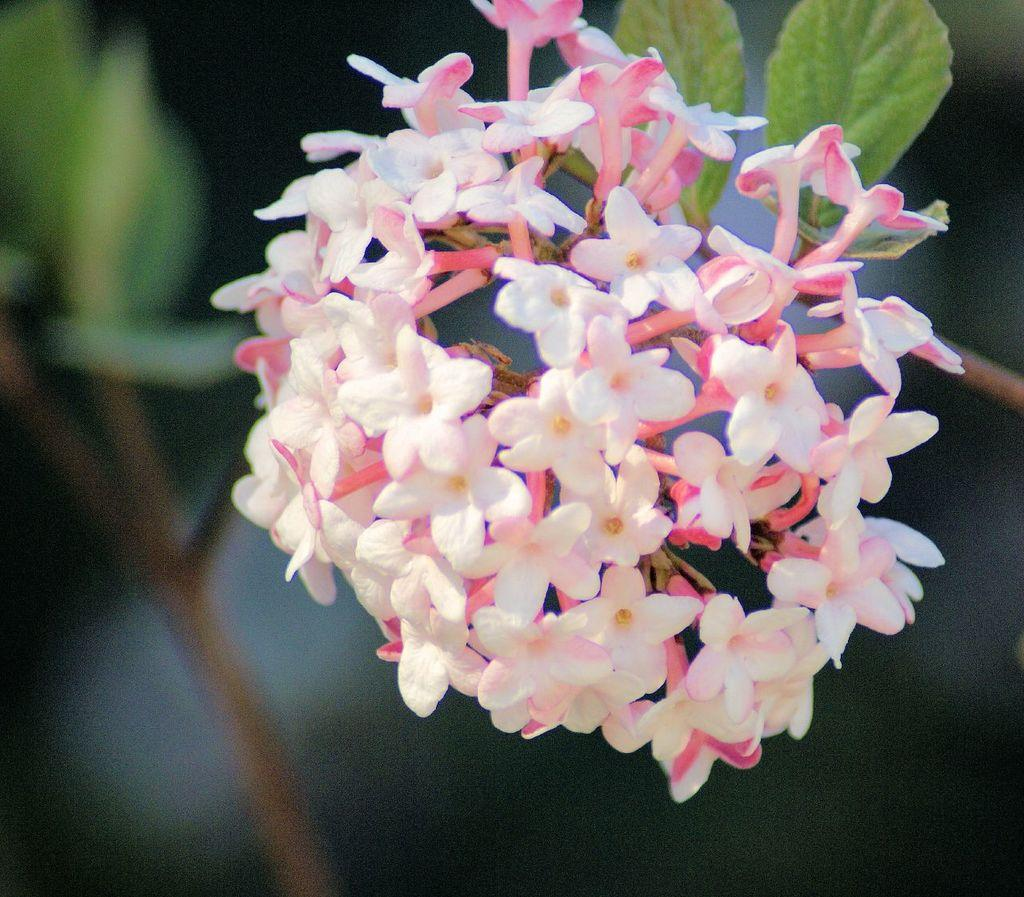What type of plants can be seen in the image? There are flowers and leaves in the image. Can you describe the background of the image? The background of the image is blurry. How many legs can be seen on the hill in the image? There is no hill or legs present in the image. What type of sea creatures can be seen swimming in the image? There is no sea or sea creatures present in the image. 